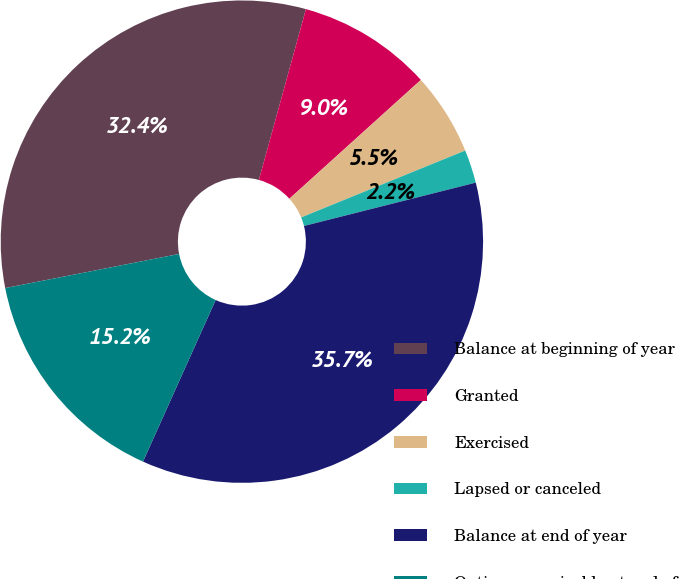Convert chart to OTSL. <chart><loc_0><loc_0><loc_500><loc_500><pie_chart><fcel>Balance at beginning of year<fcel>Granted<fcel>Exercised<fcel>Lapsed or canceled<fcel>Balance at end of year<fcel>Options exercisable at end of<nl><fcel>32.36%<fcel>9.03%<fcel>5.53%<fcel>2.23%<fcel>35.66%<fcel>15.19%<nl></chart> 